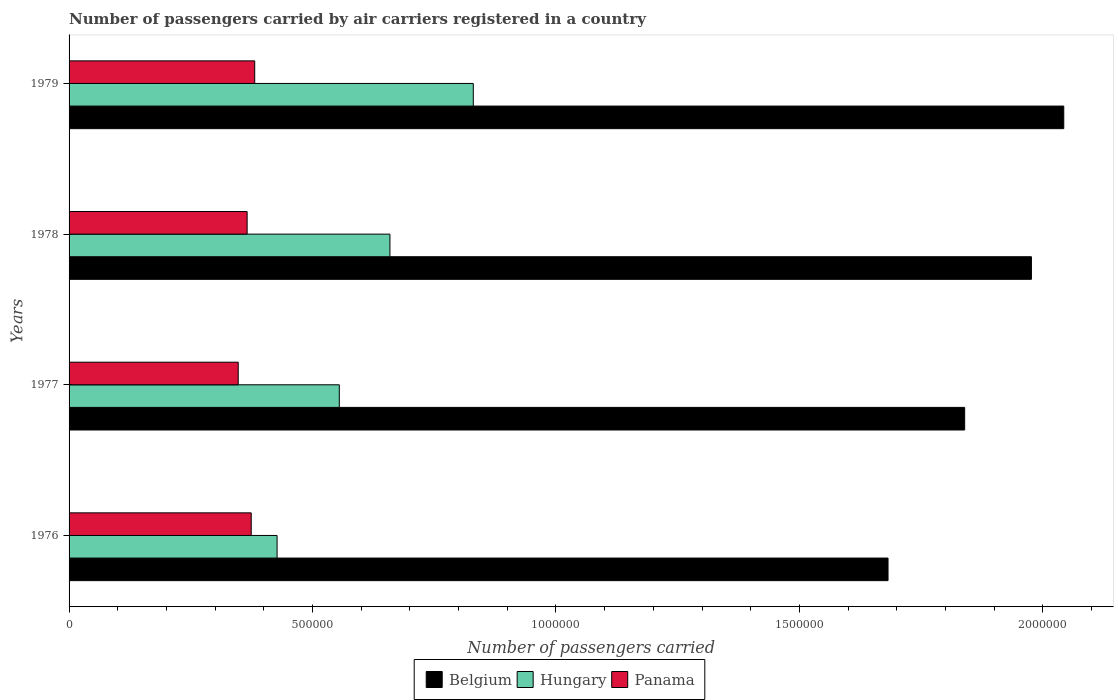Are the number of bars per tick equal to the number of legend labels?
Make the answer very short. Yes. What is the label of the 2nd group of bars from the top?
Ensure brevity in your answer.  1978. In how many cases, is the number of bars for a given year not equal to the number of legend labels?
Provide a short and direct response. 0. What is the number of passengers carried by air carriers in Belgium in 1979?
Make the answer very short. 2.04e+06. Across all years, what is the maximum number of passengers carried by air carriers in Panama?
Offer a very short reply. 3.81e+05. Across all years, what is the minimum number of passengers carried by air carriers in Hungary?
Provide a succinct answer. 4.27e+05. In which year was the number of passengers carried by air carriers in Belgium maximum?
Make the answer very short. 1979. In which year was the number of passengers carried by air carriers in Belgium minimum?
Offer a very short reply. 1976. What is the total number of passengers carried by air carriers in Panama in the graph?
Make the answer very short. 1.47e+06. What is the difference between the number of passengers carried by air carriers in Panama in 1977 and that in 1978?
Offer a very short reply. -1.83e+04. What is the difference between the number of passengers carried by air carriers in Panama in 1979 and the number of passengers carried by air carriers in Hungary in 1978?
Provide a short and direct response. -2.78e+05. What is the average number of passengers carried by air carriers in Panama per year?
Provide a succinct answer. 3.67e+05. In the year 1976, what is the difference between the number of passengers carried by air carriers in Belgium and number of passengers carried by air carriers in Hungary?
Keep it short and to the point. 1.25e+06. In how many years, is the number of passengers carried by air carriers in Hungary greater than 1900000 ?
Offer a terse response. 0. What is the ratio of the number of passengers carried by air carriers in Panama in 1976 to that in 1979?
Give a very brief answer. 0.98. Is the number of passengers carried by air carriers in Belgium in 1976 less than that in 1979?
Provide a short and direct response. Yes. What is the difference between the highest and the second highest number of passengers carried by air carriers in Panama?
Make the answer very short. 7200. What is the difference between the highest and the lowest number of passengers carried by air carriers in Belgium?
Your answer should be very brief. 3.61e+05. What does the 2nd bar from the top in 1978 represents?
Provide a short and direct response. Hungary. What does the 3rd bar from the bottom in 1978 represents?
Provide a succinct answer. Panama. Is it the case that in every year, the sum of the number of passengers carried by air carriers in Hungary and number of passengers carried by air carriers in Belgium is greater than the number of passengers carried by air carriers in Panama?
Ensure brevity in your answer.  Yes. Are all the bars in the graph horizontal?
Your answer should be very brief. Yes. How many years are there in the graph?
Offer a terse response. 4. What is the difference between two consecutive major ticks on the X-axis?
Give a very brief answer. 5.00e+05. Are the values on the major ticks of X-axis written in scientific E-notation?
Make the answer very short. No. Does the graph contain grids?
Give a very brief answer. No. Where does the legend appear in the graph?
Provide a short and direct response. Bottom center. How many legend labels are there?
Your response must be concise. 3. What is the title of the graph?
Your response must be concise. Number of passengers carried by air carriers registered in a country. What is the label or title of the X-axis?
Your response must be concise. Number of passengers carried. What is the Number of passengers carried of Belgium in 1976?
Your response must be concise. 1.68e+06. What is the Number of passengers carried in Hungary in 1976?
Ensure brevity in your answer.  4.27e+05. What is the Number of passengers carried of Panama in 1976?
Offer a terse response. 3.74e+05. What is the Number of passengers carried of Belgium in 1977?
Make the answer very short. 1.84e+06. What is the Number of passengers carried of Hungary in 1977?
Ensure brevity in your answer.  5.55e+05. What is the Number of passengers carried in Panama in 1977?
Provide a short and direct response. 3.47e+05. What is the Number of passengers carried in Belgium in 1978?
Make the answer very short. 1.98e+06. What is the Number of passengers carried of Hungary in 1978?
Your response must be concise. 6.59e+05. What is the Number of passengers carried of Panama in 1978?
Your answer should be very brief. 3.66e+05. What is the Number of passengers carried of Belgium in 1979?
Your answer should be compact. 2.04e+06. What is the Number of passengers carried in Hungary in 1979?
Offer a very short reply. 8.30e+05. What is the Number of passengers carried of Panama in 1979?
Your answer should be very brief. 3.81e+05. Across all years, what is the maximum Number of passengers carried of Belgium?
Ensure brevity in your answer.  2.04e+06. Across all years, what is the maximum Number of passengers carried of Hungary?
Offer a very short reply. 8.30e+05. Across all years, what is the maximum Number of passengers carried of Panama?
Keep it short and to the point. 3.81e+05. Across all years, what is the minimum Number of passengers carried of Belgium?
Offer a terse response. 1.68e+06. Across all years, what is the minimum Number of passengers carried of Hungary?
Give a very brief answer. 4.27e+05. Across all years, what is the minimum Number of passengers carried in Panama?
Your response must be concise. 3.47e+05. What is the total Number of passengers carried in Belgium in the graph?
Give a very brief answer. 7.54e+06. What is the total Number of passengers carried of Hungary in the graph?
Ensure brevity in your answer.  2.47e+06. What is the total Number of passengers carried in Panama in the graph?
Make the answer very short. 1.47e+06. What is the difference between the Number of passengers carried of Belgium in 1976 and that in 1977?
Give a very brief answer. -1.57e+05. What is the difference between the Number of passengers carried in Hungary in 1976 and that in 1977?
Ensure brevity in your answer.  -1.28e+05. What is the difference between the Number of passengers carried of Panama in 1976 and that in 1977?
Your answer should be compact. 2.67e+04. What is the difference between the Number of passengers carried of Belgium in 1976 and that in 1978?
Offer a very short reply. -2.94e+05. What is the difference between the Number of passengers carried in Hungary in 1976 and that in 1978?
Provide a short and direct response. -2.32e+05. What is the difference between the Number of passengers carried in Panama in 1976 and that in 1978?
Provide a short and direct response. 8400. What is the difference between the Number of passengers carried of Belgium in 1976 and that in 1979?
Give a very brief answer. -3.61e+05. What is the difference between the Number of passengers carried of Hungary in 1976 and that in 1979?
Your response must be concise. -4.03e+05. What is the difference between the Number of passengers carried of Panama in 1976 and that in 1979?
Your response must be concise. -7200. What is the difference between the Number of passengers carried of Belgium in 1977 and that in 1978?
Your response must be concise. -1.37e+05. What is the difference between the Number of passengers carried of Hungary in 1977 and that in 1978?
Your answer should be compact. -1.04e+05. What is the difference between the Number of passengers carried in Panama in 1977 and that in 1978?
Offer a very short reply. -1.83e+04. What is the difference between the Number of passengers carried of Belgium in 1977 and that in 1979?
Your answer should be very brief. -2.04e+05. What is the difference between the Number of passengers carried in Hungary in 1977 and that in 1979?
Provide a succinct answer. -2.75e+05. What is the difference between the Number of passengers carried of Panama in 1977 and that in 1979?
Keep it short and to the point. -3.39e+04. What is the difference between the Number of passengers carried of Belgium in 1978 and that in 1979?
Give a very brief answer. -6.64e+04. What is the difference between the Number of passengers carried of Hungary in 1978 and that in 1979?
Provide a succinct answer. -1.71e+05. What is the difference between the Number of passengers carried in Panama in 1978 and that in 1979?
Make the answer very short. -1.56e+04. What is the difference between the Number of passengers carried in Belgium in 1976 and the Number of passengers carried in Hungary in 1977?
Provide a succinct answer. 1.13e+06. What is the difference between the Number of passengers carried of Belgium in 1976 and the Number of passengers carried of Panama in 1977?
Make the answer very short. 1.33e+06. What is the difference between the Number of passengers carried in Hungary in 1976 and the Number of passengers carried in Panama in 1977?
Your response must be concise. 7.98e+04. What is the difference between the Number of passengers carried in Belgium in 1976 and the Number of passengers carried in Hungary in 1978?
Make the answer very short. 1.02e+06. What is the difference between the Number of passengers carried of Belgium in 1976 and the Number of passengers carried of Panama in 1978?
Provide a succinct answer. 1.32e+06. What is the difference between the Number of passengers carried of Hungary in 1976 and the Number of passengers carried of Panama in 1978?
Provide a short and direct response. 6.15e+04. What is the difference between the Number of passengers carried of Belgium in 1976 and the Number of passengers carried of Hungary in 1979?
Your response must be concise. 8.52e+05. What is the difference between the Number of passengers carried in Belgium in 1976 and the Number of passengers carried in Panama in 1979?
Provide a short and direct response. 1.30e+06. What is the difference between the Number of passengers carried of Hungary in 1976 and the Number of passengers carried of Panama in 1979?
Ensure brevity in your answer.  4.59e+04. What is the difference between the Number of passengers carried of Belgium in 1977 and the Number of passengers carried of Hungary in 1978?
Offer a terse response. 1.18e+06. What is the difference between the Number of passengers carried in Belgium in 1977 and the Number of passengers carried in Panama in 1978?
Keep it short and to the point. 1.47e+06. What is the difference between the Number of passengers carried in Hungary in 1977 and the Number of passengers carried in Panama in 1978?
Provide a succinct answer. 1.89e+05. What is the difference between the Number of passengers carried in Belgium in 1977 and the Number of passengers carried in Hungary in 1979?
Offer a terse response. 1.01e+06. What is the difference between the Number of passengers carried of Belgium in 1977 and the Number of passengers carried of Panama in 1979?
Offer a terse response. 1.46e+06. What is the difference between the Number of passengers carried of Hungary in 1977 and the Number of passengers carried of Panama in 1979?
Your answer should be very brief. 1.74e+05. What is the difference between the Number of passengers carried of Belgium in 1978 and the Number of passengers carried of Hungary in 1979?
Make the answer very short. 1.15e+06. What is the difference between the Number of passengers carried of Belgium in 1978 and the Number of passengers carried of Panama in 1979?
Your answer should be very brief. 1.60e+06. What is the difference between the Number of passengers carried of Hungary in 1978 and the Number of passengers carried of Panama in 1979?
Provide a short and direct response. 2.78e+05. What is the average Number of passengers carried in Belgium per year?
Make the answer very short. 1.89e+06. What is the average Number of passengers carried in Hungary per year?
Offer a terse response. 6.18e+05. What is the average Number of passengers carried of Panama per year?
Ensure brevity in your answer.  3.67e+05. In the year 1976, what is the difference between the Number of passengers carried in Belgium and Number of passengers carried in Hungary?
Offer a terse response. 1.25e+06. In the year 1976, what is the difference between the Number of passengers carried of Belgium and Number of passengers carried of Panama?
Provide a short and direct response. 1.31e+06. In the year 1976, what is the difference between the Number of passengers carried in Hungary and Number of passengers carried in Panama?
Make the answer very short. 5.31e+04. In the year 1977, what is the difference between the Number of passengers carried of Belgium and Number of passengers carried of Hungary?
Provide a short and direct response. 1.28e+06. In the year 1977, what is the difference between the Number of passengers carried of Belgium and Number of passengers carried of Panama?
Give a very brief answer. 1.49e+06. In the year 1977, what is the difference between the Number of passengers carried of Hungary and Number of passengers carried of Panama?
Provide a short and direct response. 2.08e+05. In the year 1978, what is the difference between the Number of passengers carried in Belgium and Number of passengers carried in Hungary?
Make the answer very short. 1.32e+06. In the year 1978, what is the difference between the Number of passengers carried of Belgium and Number of passengers carried of Panama?
Ensure brevity in your answer.  1.61e+06. In the year 1978, what is the difference between the Number of passengers carried in Hungary and Number of passengers carried in Panama?
Offer a very short reply. 2.93e+05. In the year 1979, what is the difference between the Number of passengers carried of Belgium and Number of passengers carried of Hungary?
Your answer should be very brief. 1.21e+06. In the year 1979, what is the difference between the Number of passengers carried of Belgium and Number of passengers carried of Panama?
Your answer should be very brief. 1.66e+06. In the year 1979, what is the difference between the Number of passengers carried of Hungary and Number of passengers carried of Panama?
Provide a succinct answer. 4.49e+05. What is the ratio of the Number of passengers carried in Belgium in 1976 to that in 1977?
Your answer should be compact. 0.91. What is the ratio of the Number of passengers carried in Hungary in 1976 to that in 1977?
Your answer should be very brief. 0.77. What is the ratio of the Number of passengers carried in Panama in 1976 to that in 1977?
Your response must be concise. 1.08. What is the ratio of the Number of passengers carried of Belgium in 1976 to that in 1978?
Your response must be concise. 0.85. What is the ratio of the Number of passengers carried of Hungary in 1976 to that in 1978?
Ensure brevity in your answer.  0.65. What is the ratio of the Number of passengers carried of Belgium in 1976 to that in 1979?
Give a very brief answer. 0.82. What is the ratio of the Number of passengers carried in Hungary in 1976 to that in 1979?
Make the answer very short. 0.51. What is the ratio of the Number of passengers carried in Panama in 1976 to that in 1979?
Your answer should be compact. 0.98. What is the ratio of the Number of passengers carried in Belgium in 1977 to that in 1978?
Ensure brevity in your answer.  0.93. What is the ratio of the Number of passengers carried of Hungary in 1977 to that in 1978?
Offer a very short reply. 0.84. What is the ratio of the Number of passengers carried of Belgium in 1977 to that in 1979?
Ensure brevity in your answer.  0.9. What is the ratio of the Number of passengers carried of Hungary in 1977 to that in 1979?
Your answer should be very brief. 0.67. What is the ratio of the Number of passengers carried in Panama in 1977 to that in 1979?
Your response must be concise. 0.91. What is the ratio of the Number of passengers carried of Belgium in 1978 to that in 1979?
Your answer should be compact. 0.97. What is the ratio of the Number of passengers carried of Hungary in 1978 to that in 1979?
Your response must be concise. 0.79. What is the ratio of the Number of passengers carried in Panama in 1978 to that in 1979?
Provide a short and direct response. 0.96. What is the difference between the highest and the second highest Number of passengers carried of Belgium?
Your response must be concise. 6.64e+04. What is the difference between the highest and the second highest Number of passengers carried in Hungary?
Your answer should be compact. 1.71e+05. What is the difference between the highest and the second highest Number of passengers carried in Panama?
Ensure brevity in your answer.  7200. What is the difference between the highest and the lowest Number of passengers carried in Belgium?
Keep it short and to the point. 3.61e+05. What is the difference between the highest and the lowest Number of passengers carried in Hungary?
Make the answer very short. 4.03e+05. What is the difference between the highest and the lowest Number of passengers carried of Panama?
Ensure brevity in your answer.  3.39e+04. 